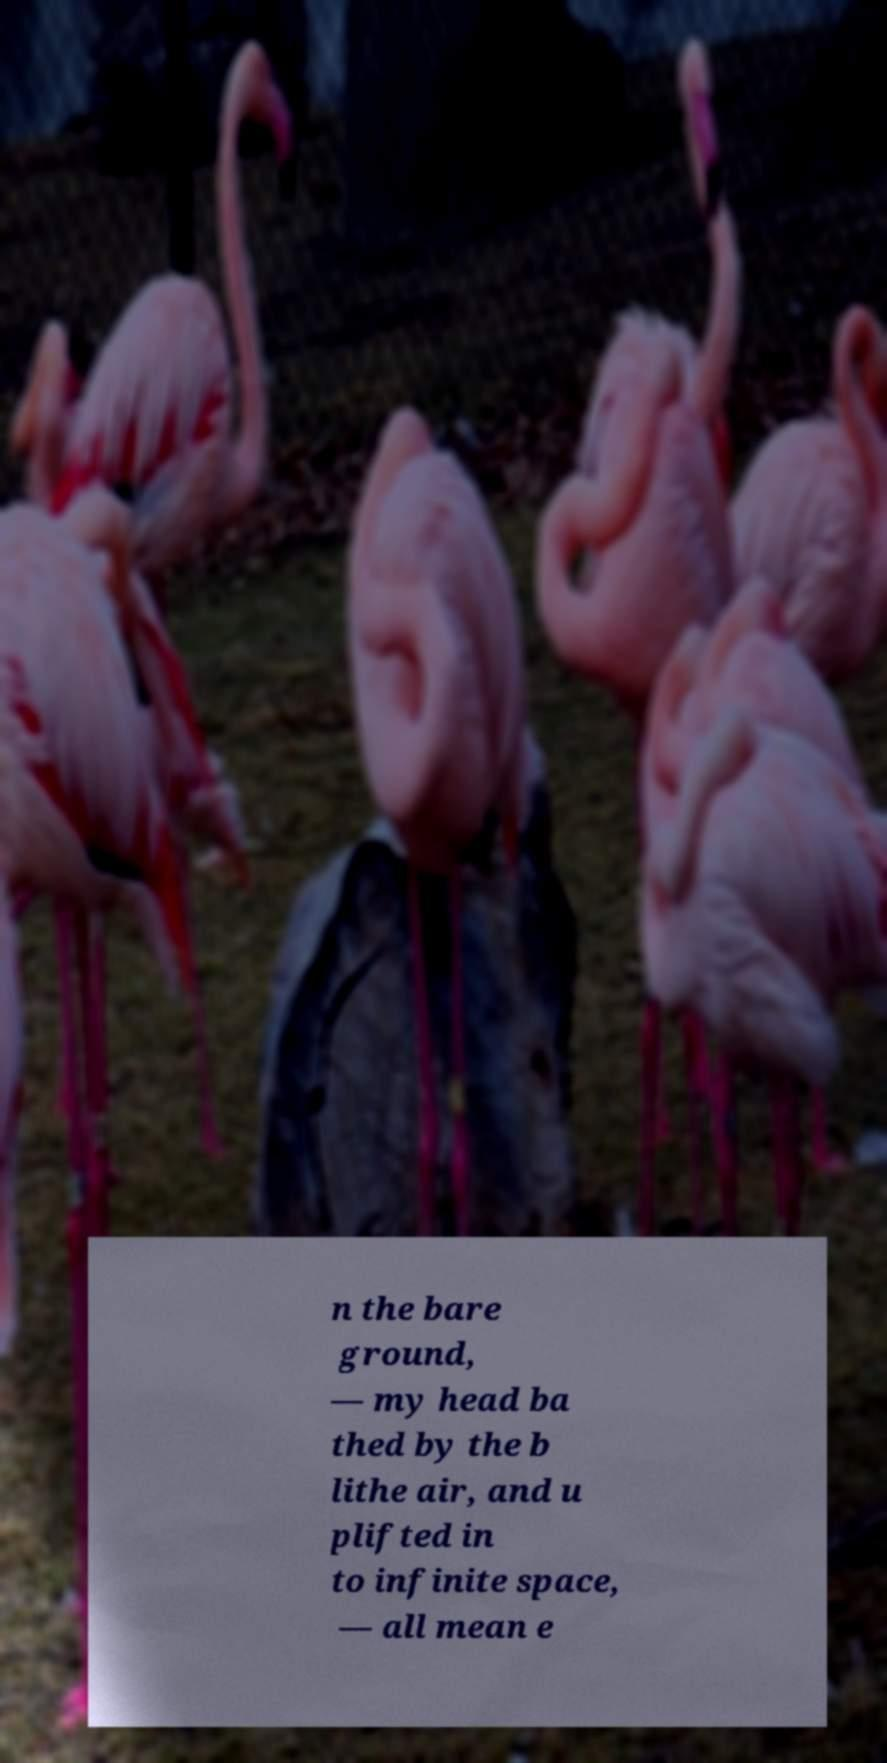What messages or text are displayed in this image? I need them in a readable, typed format. n the bare ground, — my head ba thed by the b lithe air, and u plifted in to infinite space, — all mean e 